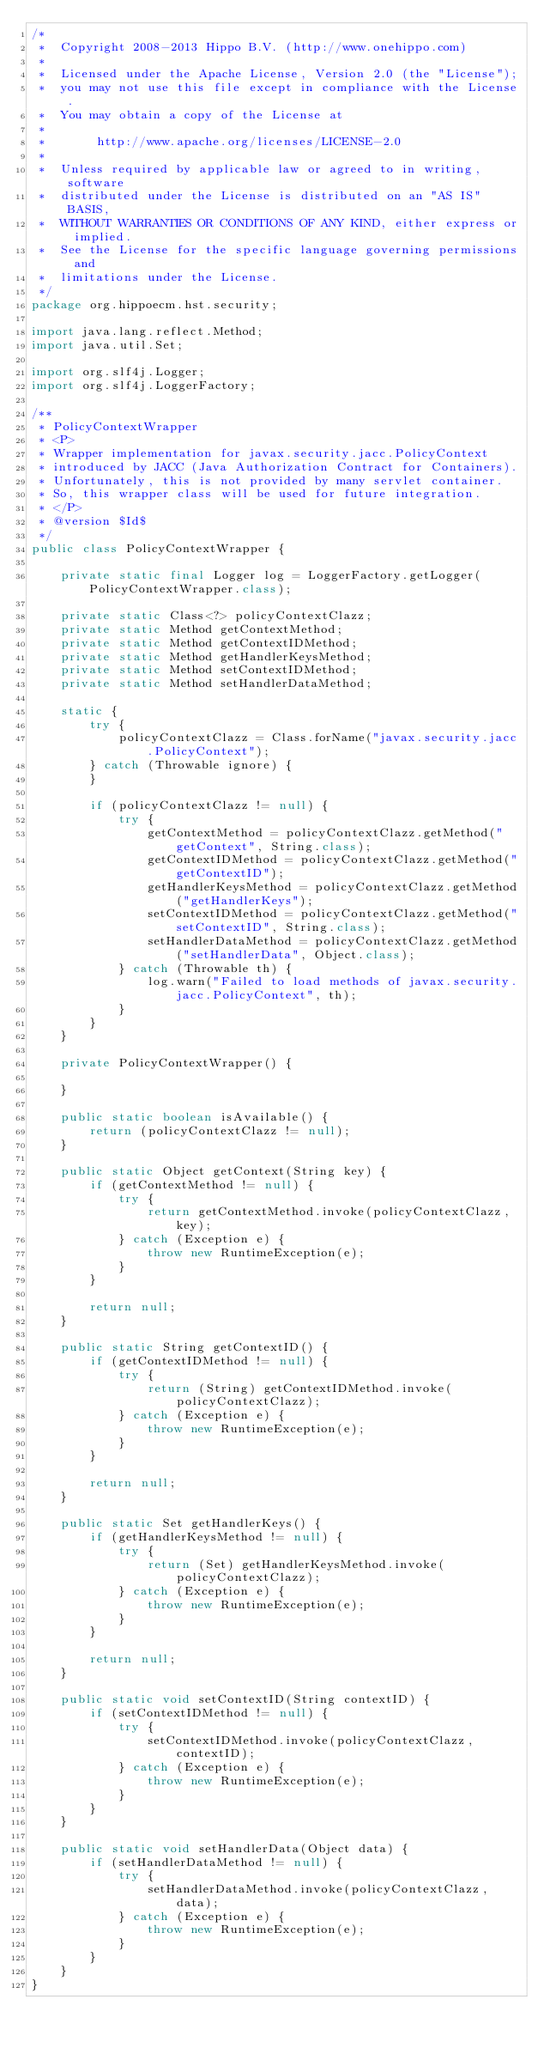Convert code to text. <code><loc_0><loc_0><loc_500><loc_500><_Java_>/*
 *  Copyright 2008-2013 Hippo B.V. (http://www.onehippo.com)
 * 
 *  Licensed under the Apache License, Version 2.0 (the "License");
 *  you may not use this file except in compliance with the License.
 *  You may obtain a copy of the License at
 * 
 *       http://www.apache.org/licenses/LICENSE-2.0
 * 
 *  Unless required by applicable law or agreed to in writing, software
 *  distributed under the License is distributed on an "AS IS" BASIS,
 *  WITHOUT WARRANTIES OR CONDITIONS OF ANY KIND, either express or implied.
 *  See the License for the specific language governing permissions and
 *  limitations under the License.
 */
package org.hippoecm.hst.security;

import java.lang.reflect.Method;
import java.util.Set;

import org.slf4j.Logger;
import org.slf4j.LoggerFactory;

/**
 * PolicyContextWrapper
 * <P>
 * Wrapper implementation for javax.security.jacc.PolicyContext
 * introduced by JACC (Java Authorization Contract for Containers).
 * Unfortunately, this is not provided by many servlet container.
 * So, this wrapper class will be used for future integration.
 * </P>
 * @version $Id$
 */
public class PolicyContextWrapper {

    private static final Logger log = LoggerFactory.getLogger(PolicyContextWrapper.class);
    
    private static Class<?> policyContextClazz;
    private static Method getContextMethod;
    private static Method getContextIDMethod;
    private static Method getHandlerKeysMethod;
    private static Method setContextIDMethod;
    private static Method setHandlerDataMethod;
    
    static {
        try {
            policyContextClazz = Class.forName("javax.security.jacc.PolicyContext");
        } catch (Throwable ignore) {
        }
        
        if (policyContextClazz != null) {
            try {
                getContextMethod = policyContextClazz.getMethod("getContext", String.class);
                getContextIDMethod = policyContextClazz.getMethod("getContextID");
                getHandlerKeysMethod = policyContextClazz.getMethod("getHandlerKeys");
                setContextIDMethod = policyContextClazz.getMethod("setContextID", String.class);
                setHandlerDataMethod = policyContextClazz.getMethod("setHandlerData", Object.class);
            } catch (Throwable th) {
                log.warn("Failed to load methods of javax.security.jacc.PolicyContext", th);
            }
        }
    }
    
    private PolicyContextWrapper() {
        
    }
    
    public static boolean isAvailable() {
        return (policyContextClazz != null);
    }
    
    public static Object getContext(String key) {
        if (getContextMethod != null) {
            try {
                return getContextMethod.invoke(policyContextClazz, key);
            } catch (Exception e) {
                throw new RuntimeException(e);
            }
        }
        
        return null;
    }
    
    public static String getContextID() {
        if (getContextIDMethod != null) {
            try {
                return (String) getContextIDMethod.invoke(policyContextClazz);
            } catch (Exception e) {
                throw new RuntimeException(e);
            }
        }
        
        return null;
    }
    
    public static Set getHandlerKeys() {
        if (getHandlerKeysMethod != null) {
            try {
                return (Set) getHandlerKeysMethod.invoke(policyContextClazz);
            } catch (Exception e) {
                throw new RuntimeException(e);
            }
        }
        
        return null;
    }
    
    public static void setContextID(String contextID) {
        if (setContextIDMethod != null) {
            try {
                setContextIDMethod.invoke(policyContextClazz, contextID);
            } catch (Exception e) {
                throw new RuntimeException(e);
            }
        }
    }
    
    public static void setHandlerData(Object data) {
        if (setHandlerDataMethod != null) {
            try {
                setHandlerDataMethod.invoke(policyContextClazz, data);
            } catch (Exception e) {
                throw new RuntimeException(e);
            }
        }
    }
}
</code> 